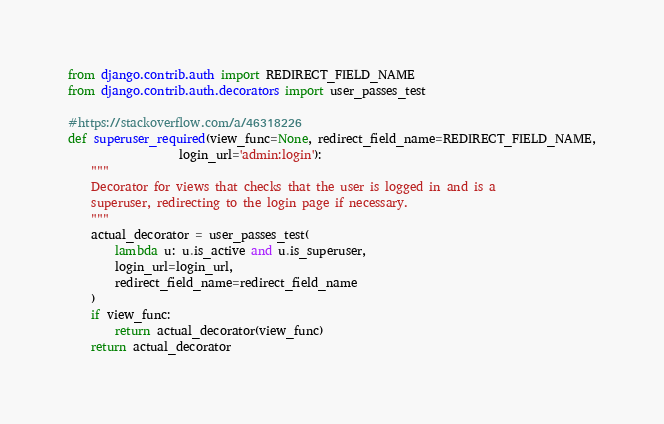Convert code to text. <code><loc_0><loc_0><loc_500><loc_500><_Python_>from django.contrib.auth import REDIRECT_FIELD_NAME
from django.contrib.auth.decorators import user_passes_test

#https://stackoverflow.com/a/46318226
def superuser_required(view_func=None, redirect_field_name=REDIRECT_FIELD_NAME,
                   login_url='admin:login'):
    """
    Decorator for views that checks that the user is logged in and is a
    superuser, redirecting to the login page if necessary.
    """
    actual_decorator = user_passes_test(
        lambda u: u.is_active and u.is_superuser,
        login_url=login_url,
        redirect_field_name=redirect_field_name
    )
    if view_func:
        return actual_decorator(view_func)
    return actual_decorator</code> 